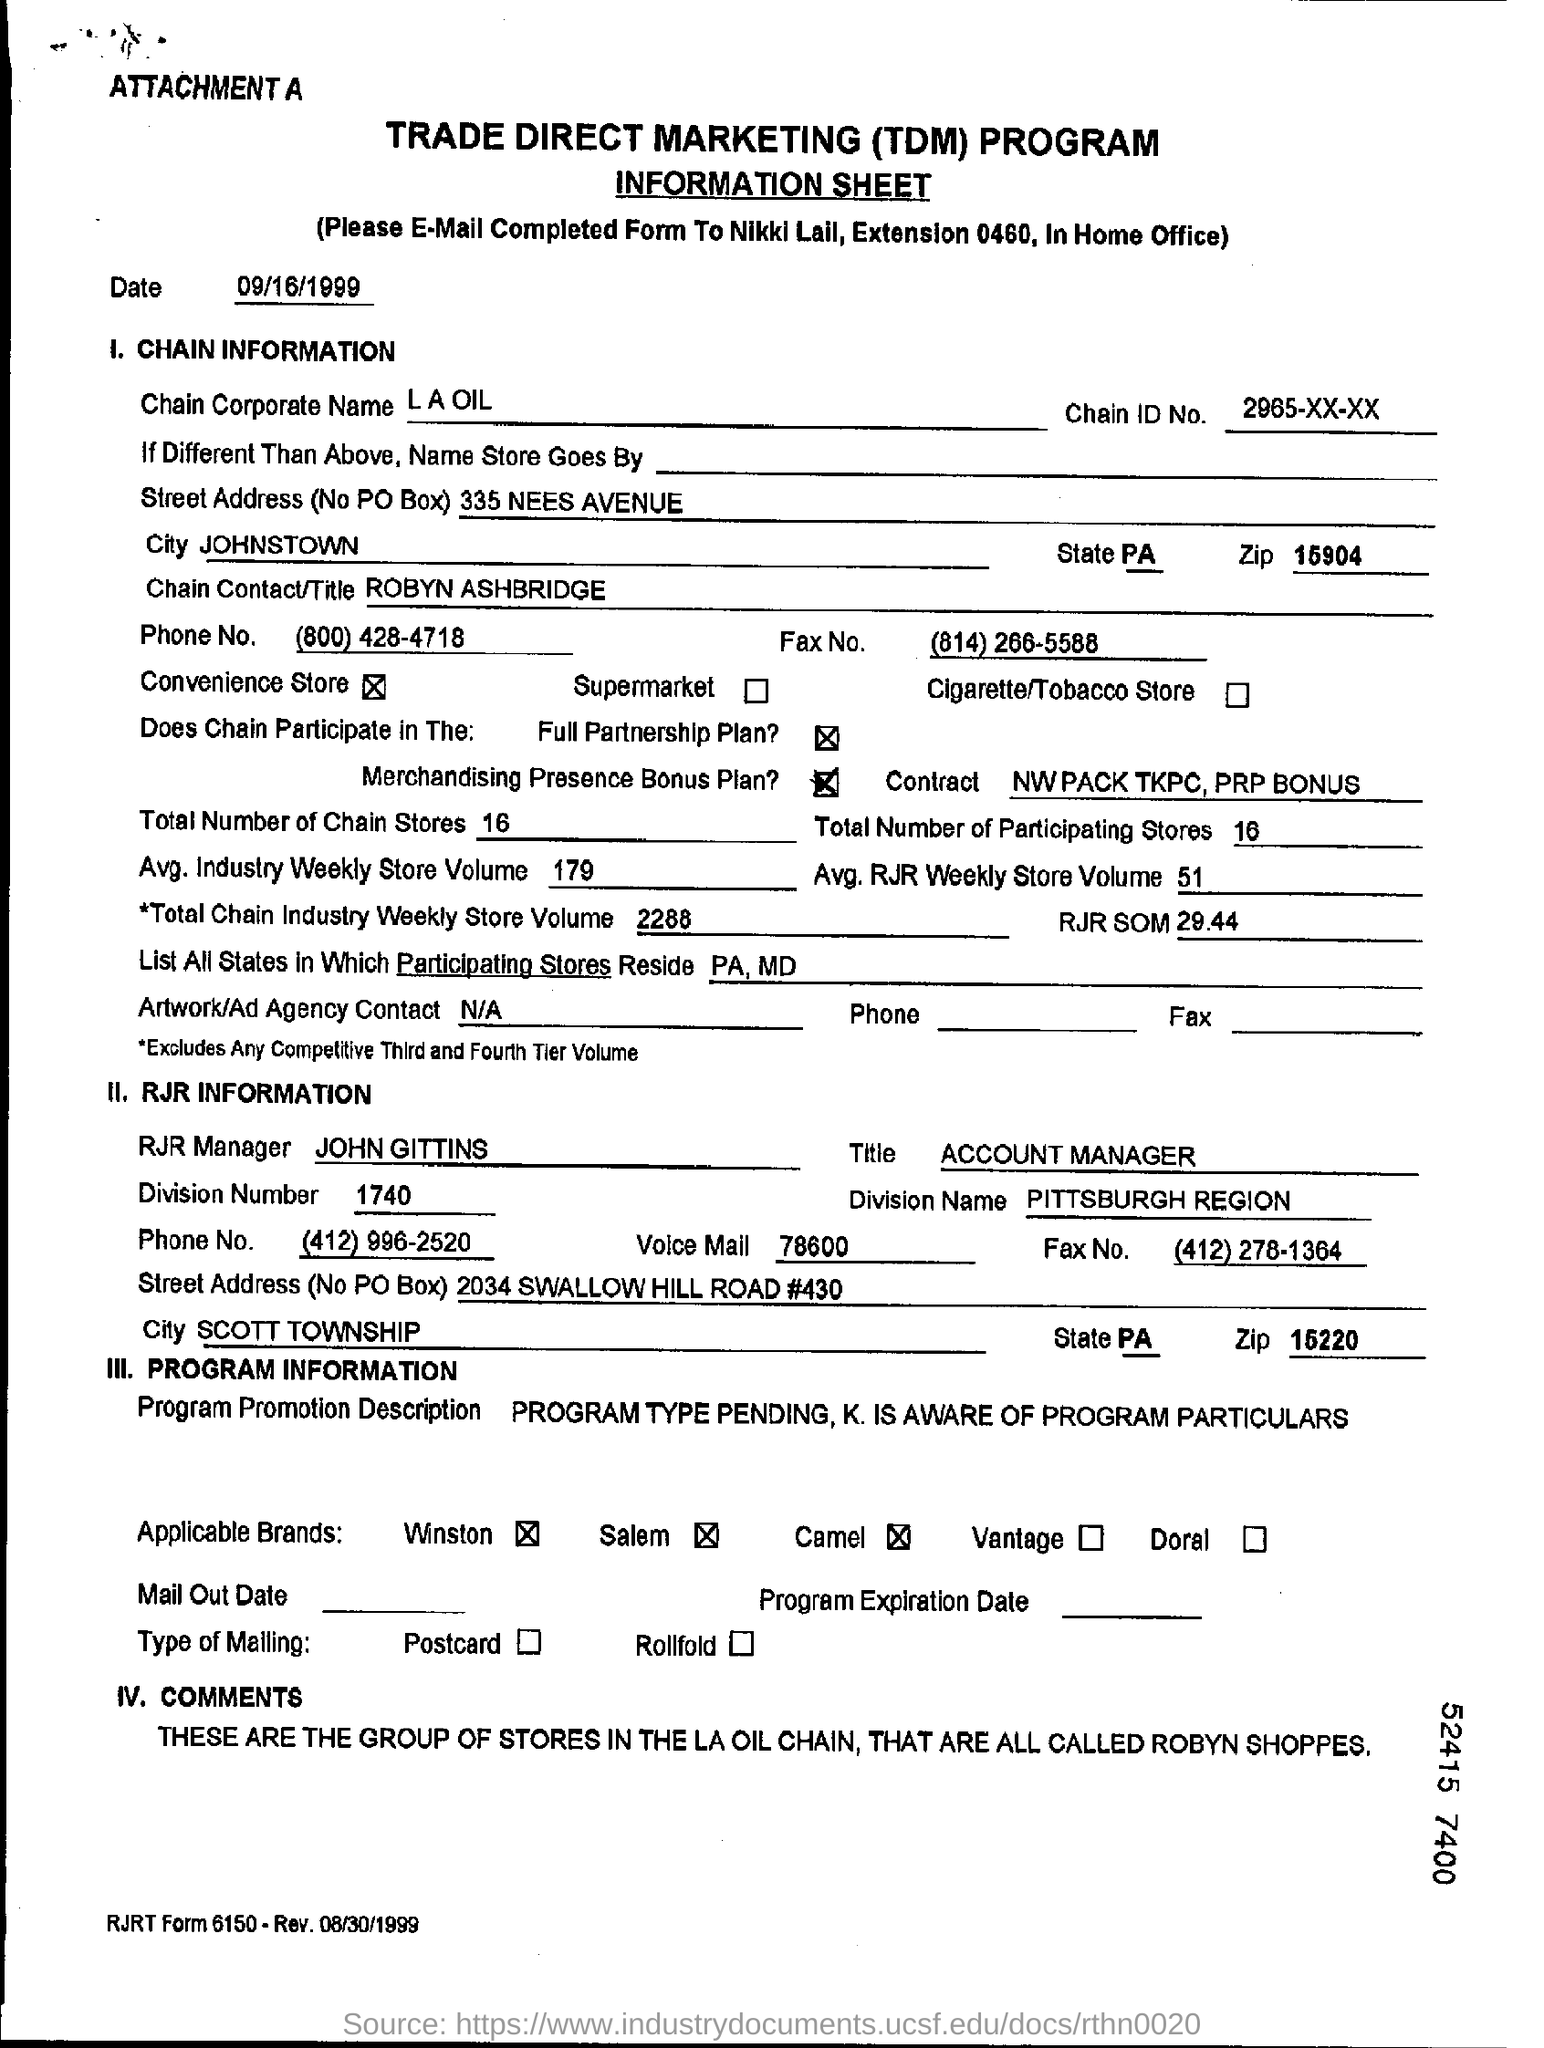What is the chain corporate name?
Offer a very short reply. L A OIL. What is chain ID No ?
Your answer should be very brief. 2965-xx-xx. What is RJR Manager name ?
Keep it short and to the point. John gittins. What is the chain contact/title ?
Your response must be concise. Robyn ashbridge. 